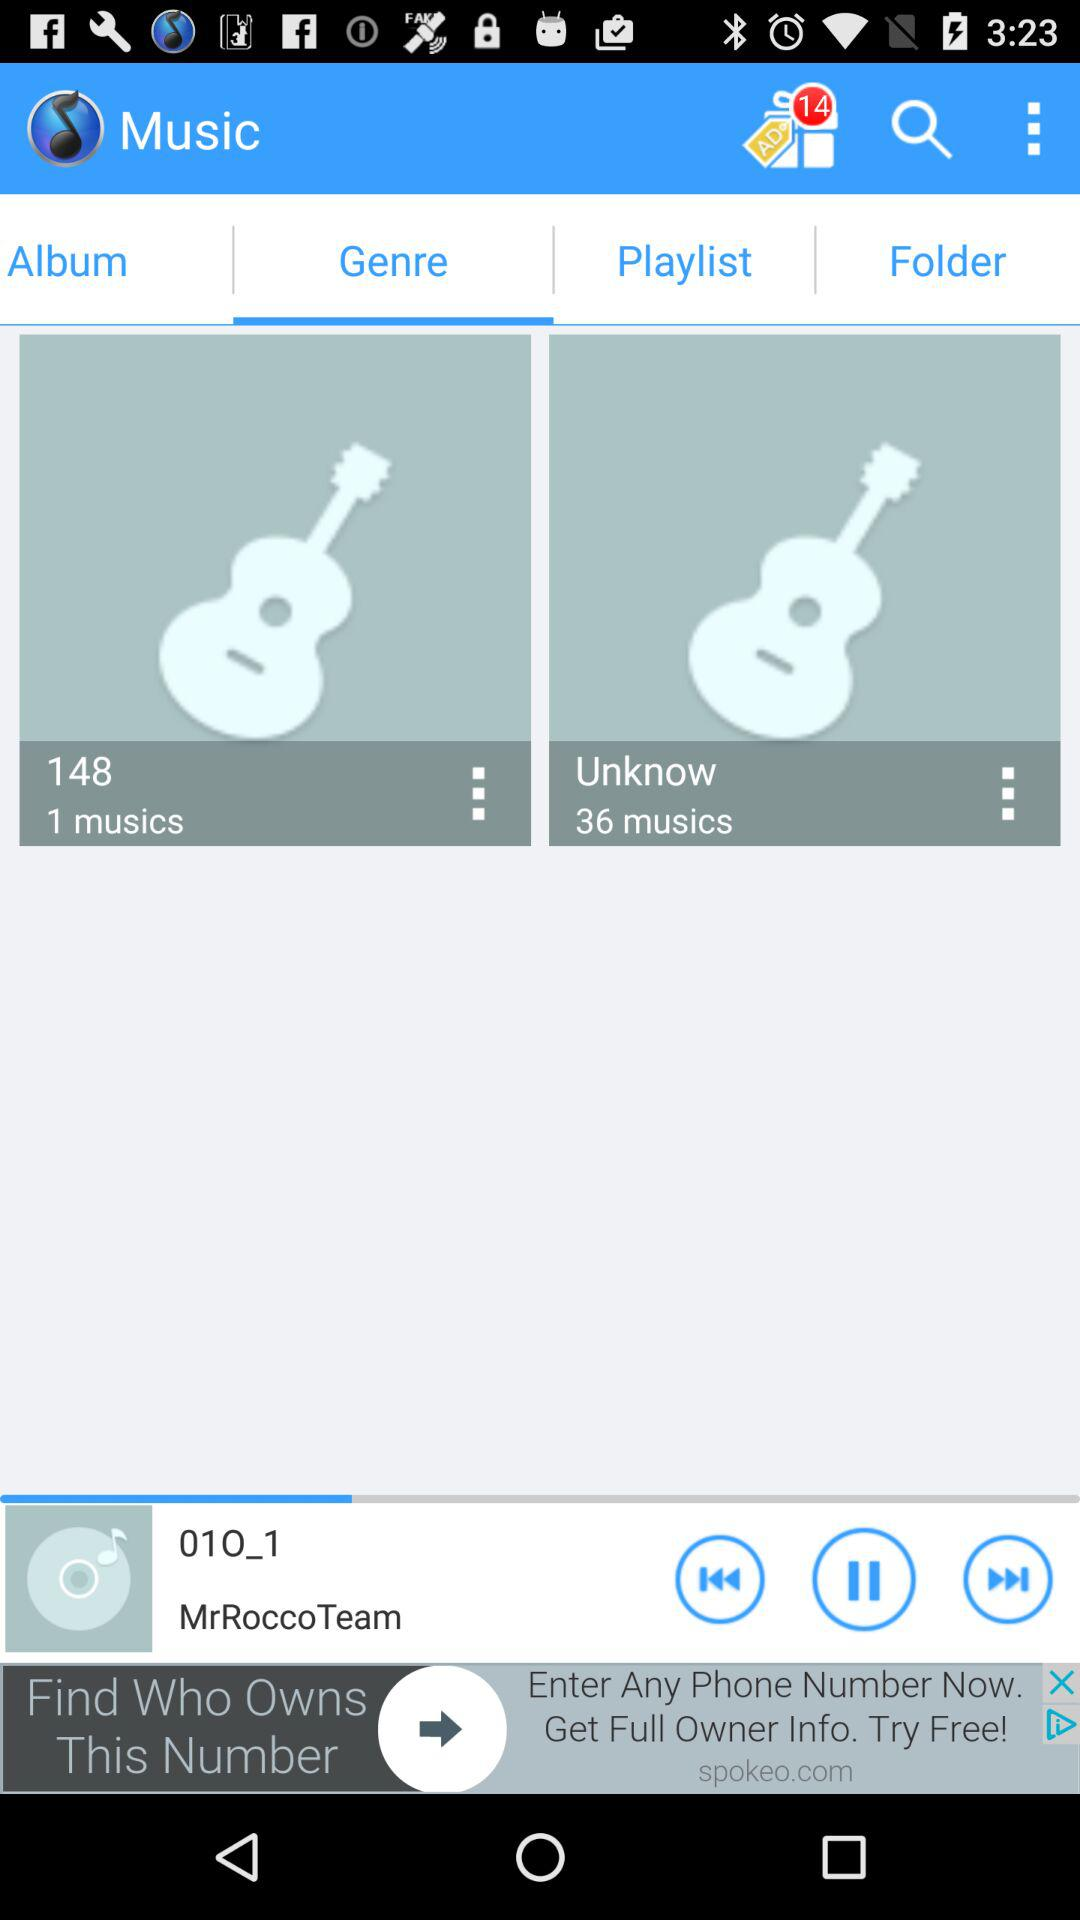How many music is there in the "Unknow" folder? There are 36 musics in the "Unknow" folder. 